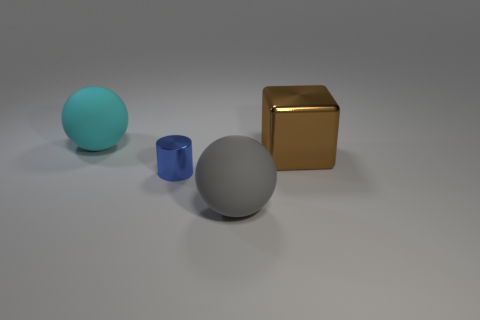Are there the same number of brown objects behind the large cyan sphere and big objects? no 